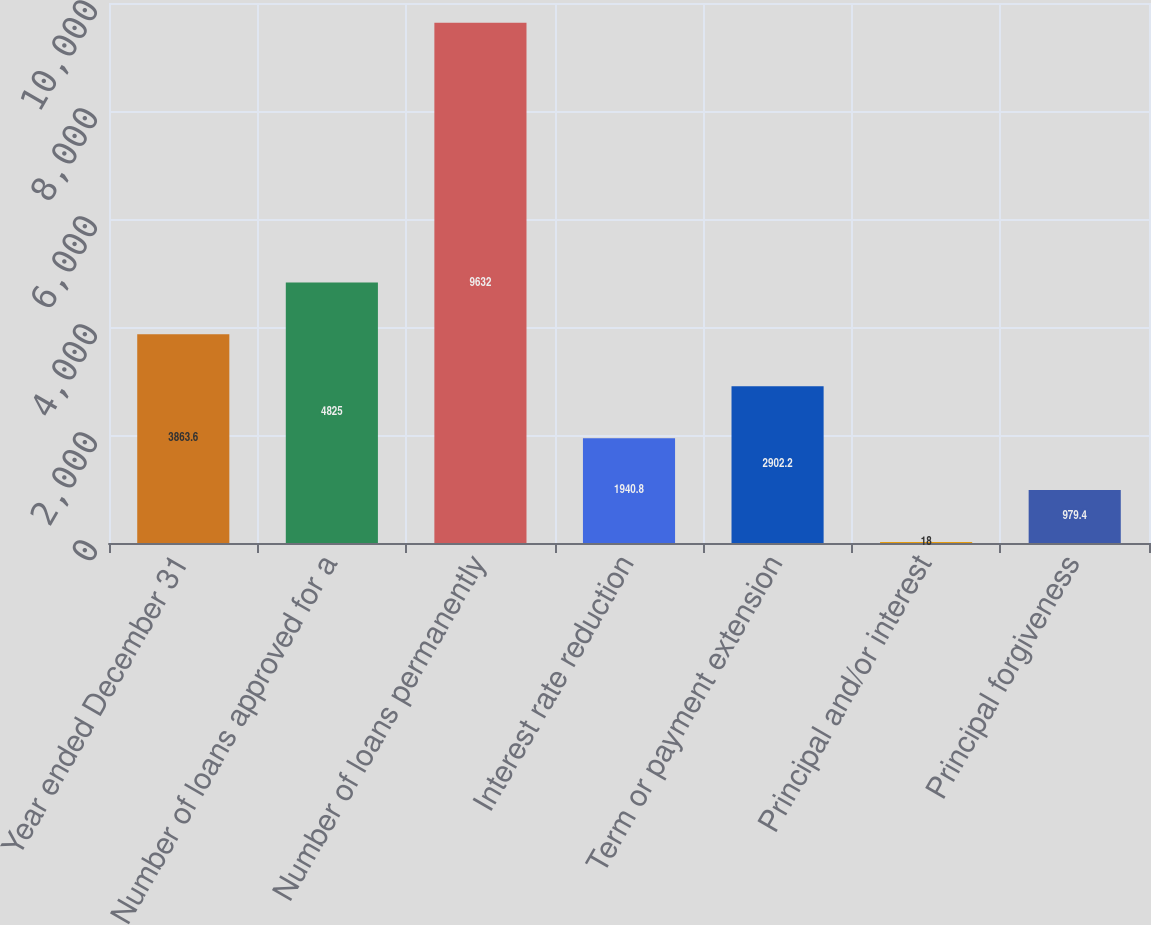Convert chart to OTSL. <chart><loc_0><loc_0><loc_500><loc_500><bar_chart><fcel>Year ended December 31<fcel>Number of loans approved for a<fcel>Number of loans permanently<fcel>Interest rate reduction<fcel>Term or payment extension<fcel>Principal and/or interest<fcel>Principal forgiveness<nl><fcel>3863.6<fcel>4825<fcel>9632<fcel>1940.8<fcel>2902.2<fcel>18<fcel>979.4<nl></chart> 